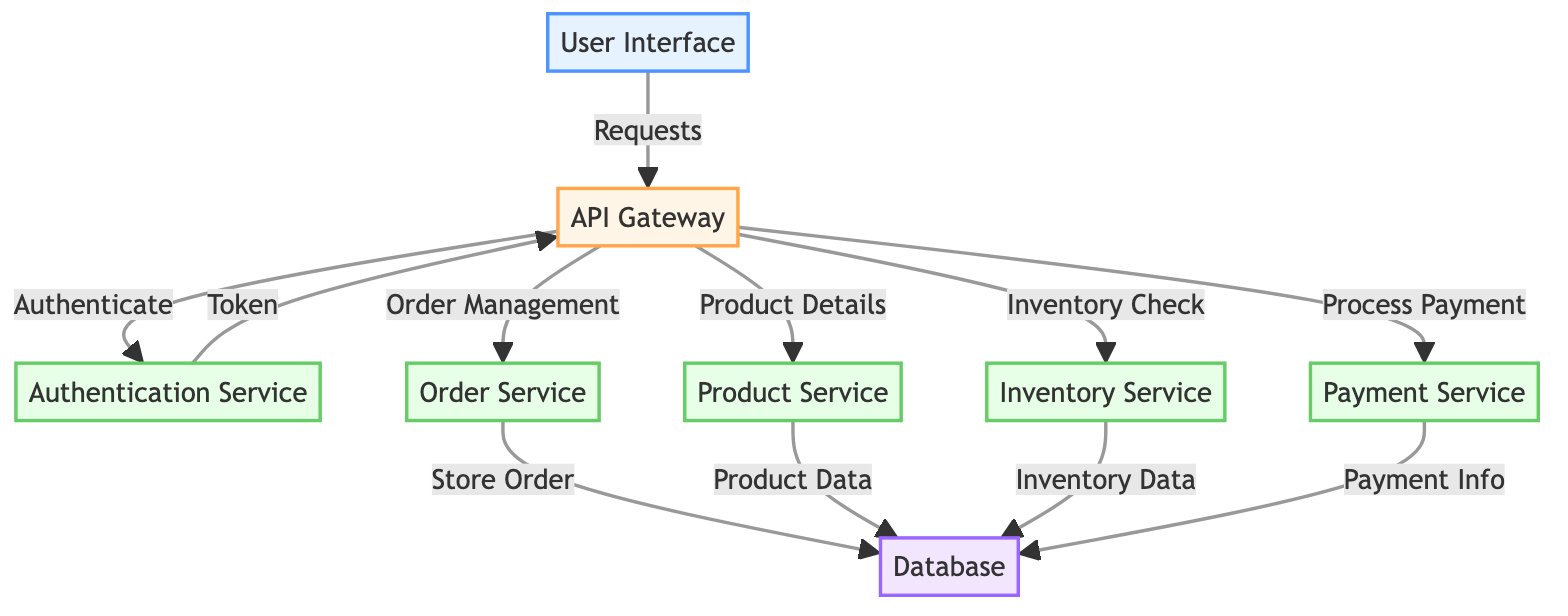What is the user interface's role in this architecture? The User Interface serves as the entry point for users, initiating requests to the API Gateway.
Answer: Entry point How many microservices are present in the diagram? The diagram shows five microservices: Authentication Service, Order Service, Product Service, Inventory Service, and Payment Service.
Answer: Five Which service does the API Gateway authenticate with? The API Gateway authenticates requests with the Authentication Service.
Answer: Authentication Service What type of database is associated with the microservices? The database mentioned in the diagram is labeled simply as "Database."
Answer: Database How does the Order Service store information? The Order Service stores order information in the Database. This is depicted by a connection labeled "Store Order."
Answer: Store Order What is the communication flow from the User Interface to the Payment Service? The flow starts at the User Interface, which sends a request to the API Gateway. The API Gateway then directs the flow to the Payment Service to process payment.
Answer: User Interface → API Gateway → Payment Service Which microservice retrieves Product Data from the Database? The Product Service is responsible for retrieving Product Data from the Database, as indicated by the connection in the diagram.
Answer: Product Service What is the significance of the token in the authentication process? The token is issued by the Authentication Service to the API Gateway, confirming a successful authentication step before subsequent requests are handled.
Answer: Token What type of service appears to manage inventory checks? The service that manages inventory checks is labeled as Inventory Service in the diagram.
Answer: Inventory Service 